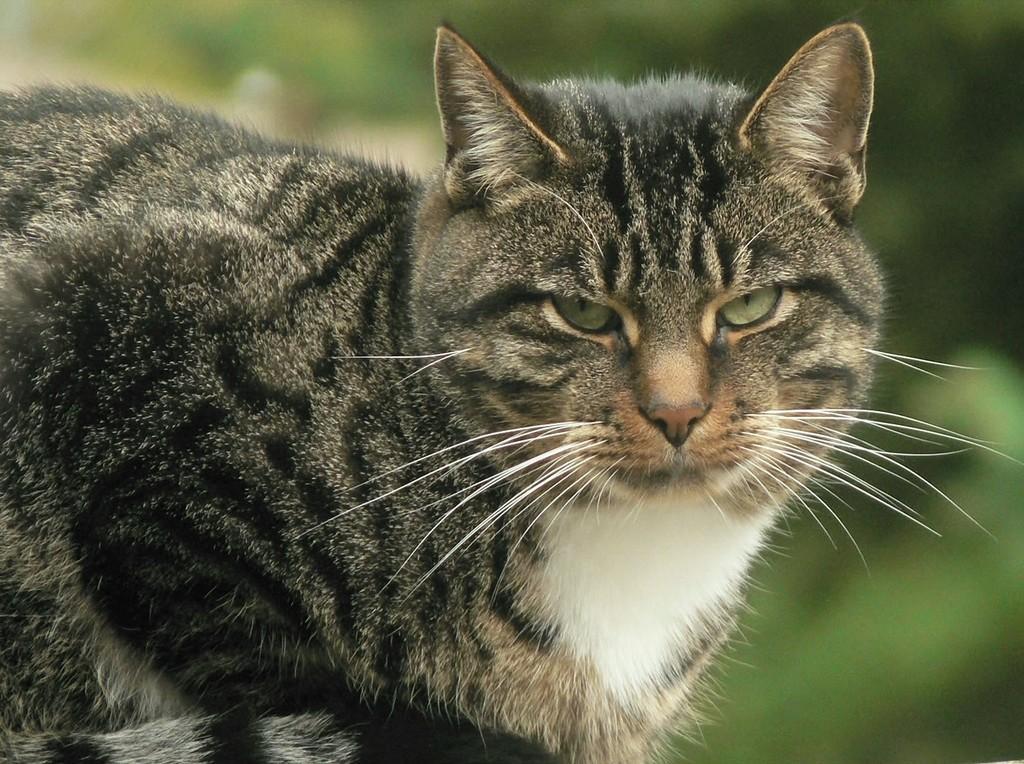Describe this image in one or two sentences. In the image we can see a cat. Background of the image is blur. 